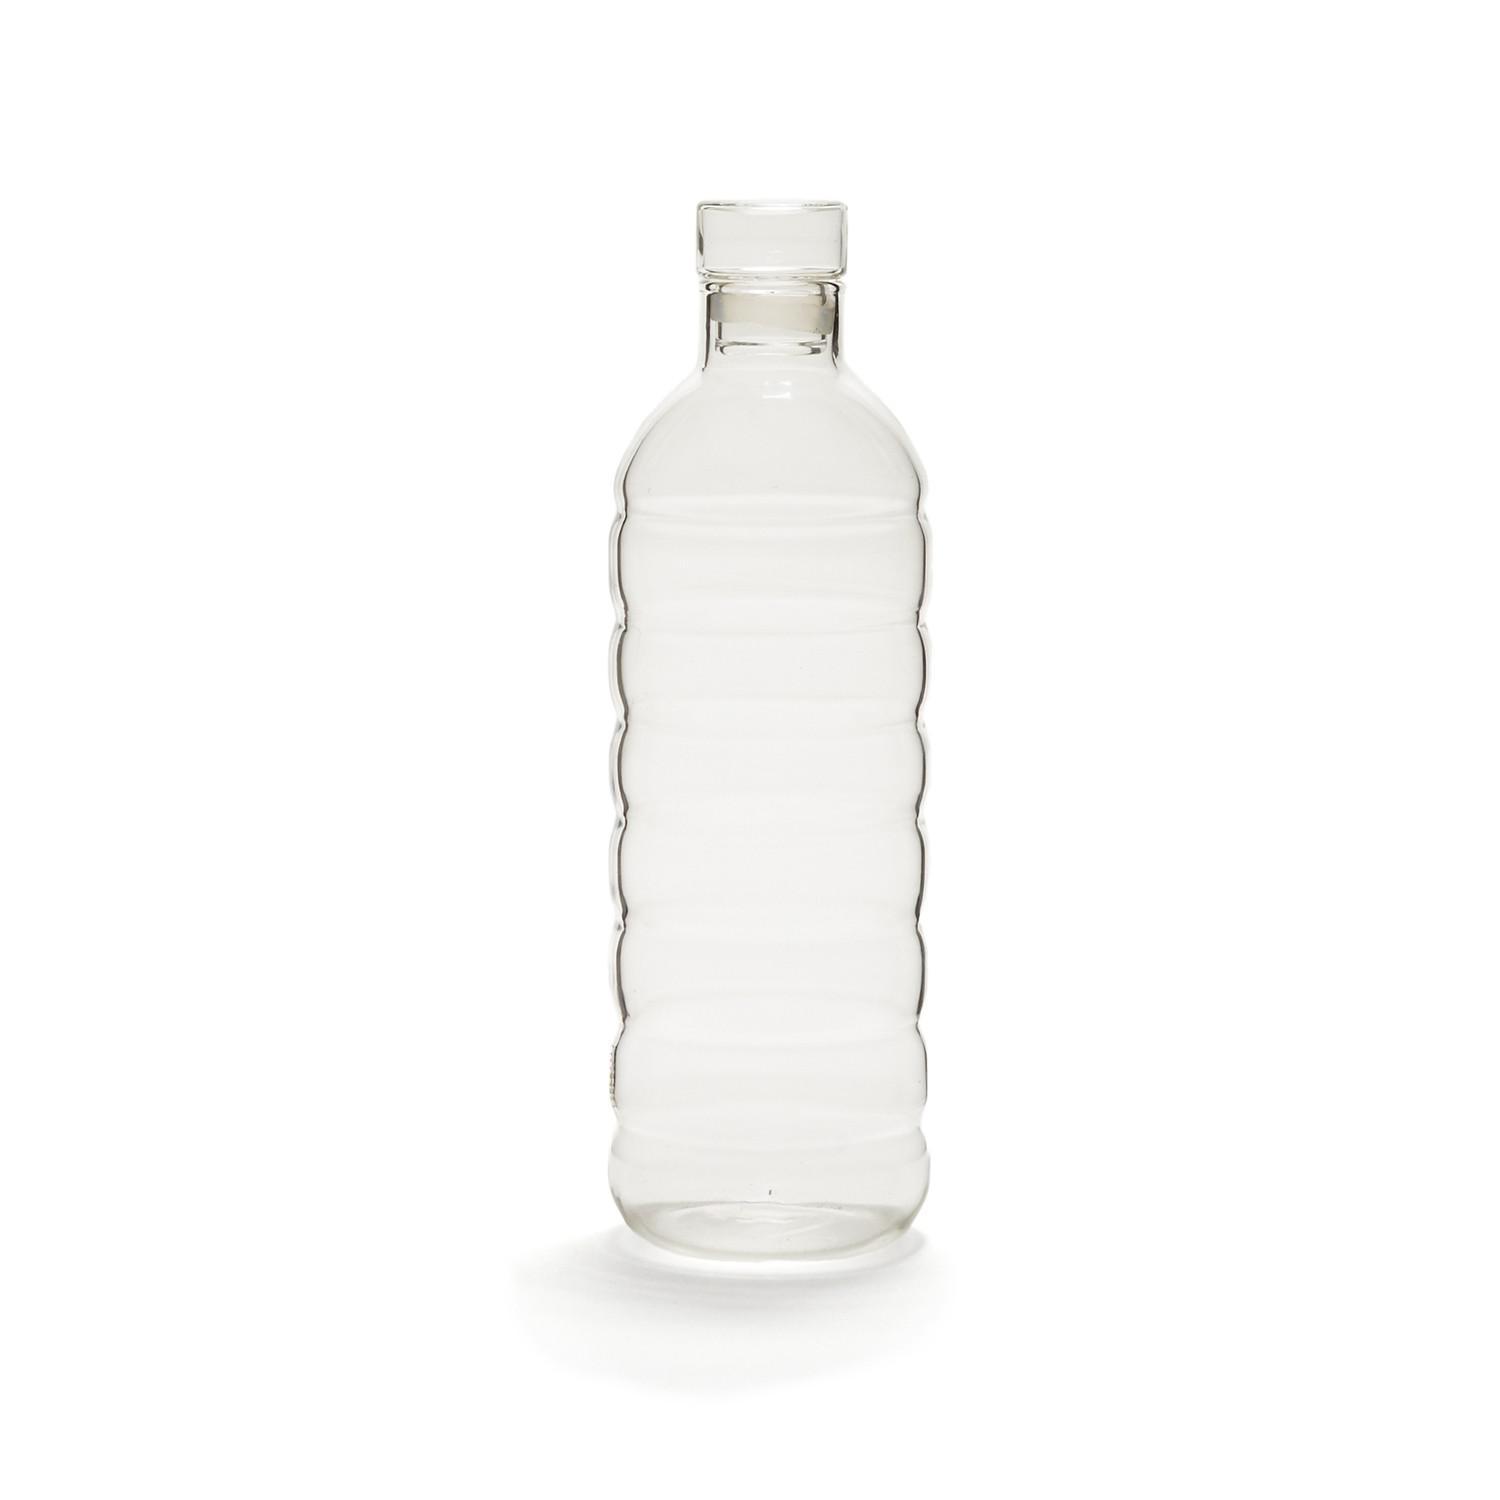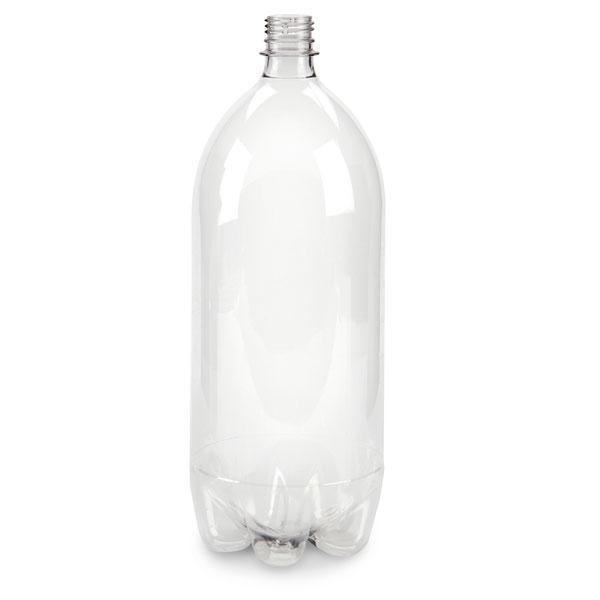The first image is the image on the left, the second image is the image on the right. Evaluate the accuracy of this statement regarding the images: "Each image shows one clear bottle, and the bottle on the left has a white lid on and is mostly cylindrical with at least one ribbed part, while the righthand bottle doesn't have its cap on.". Is it true? Answer yes or no. Yes. 